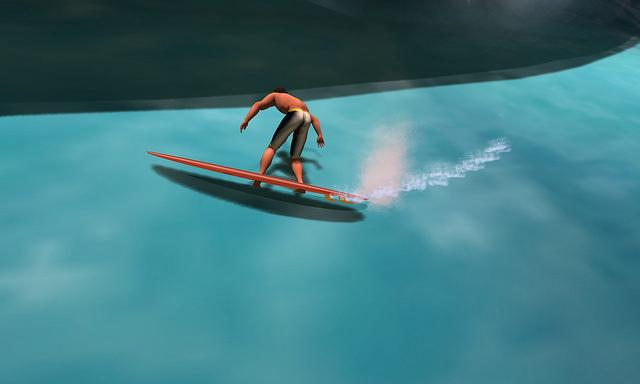How was this artwork created? computer 